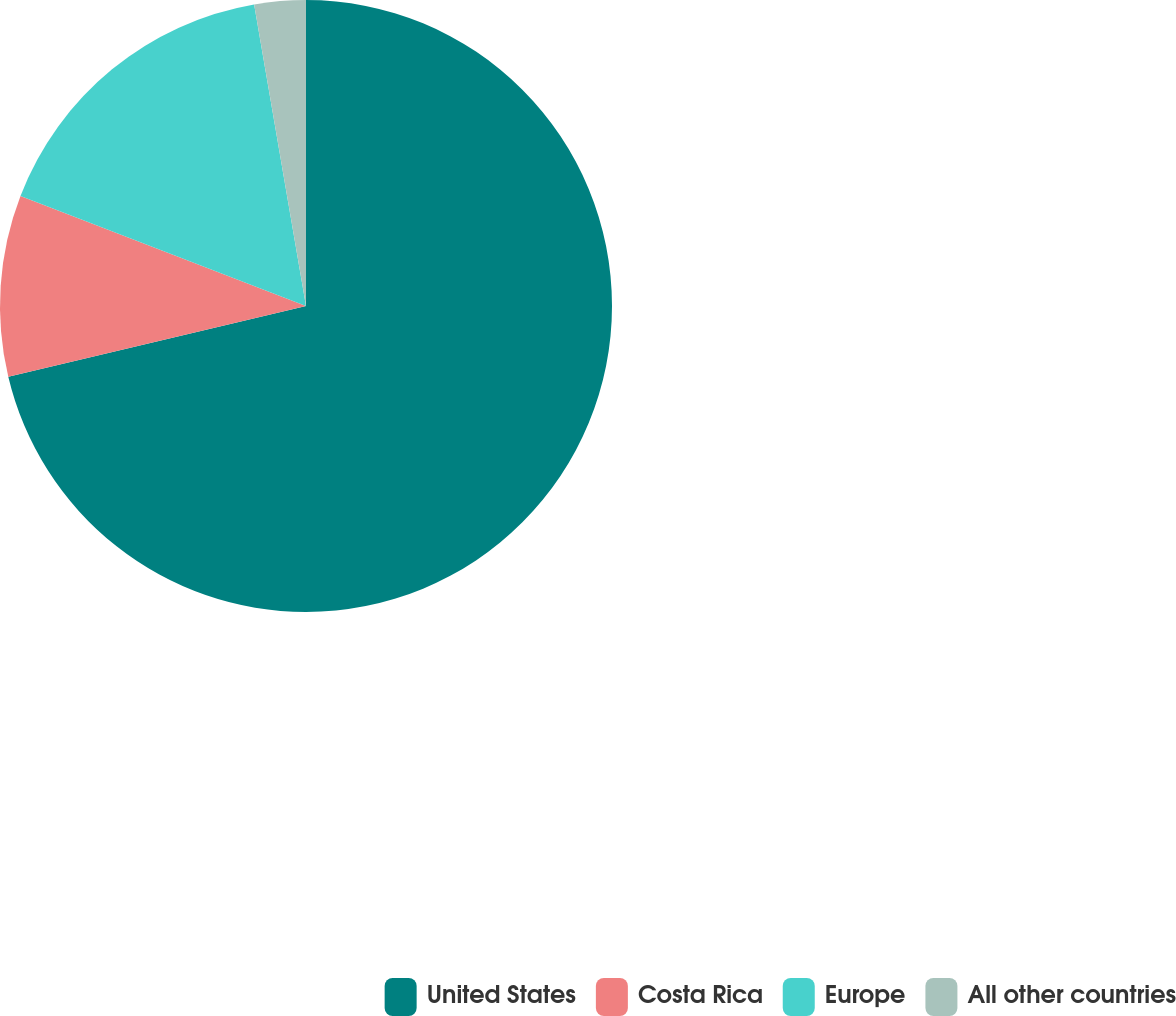Convert chart to OTSL. <chart><loc_0><loc_0><loc_500><loc_500><pie_chart><fcel>United States<fcel>Costa Rica<fcel>Europe<fcel>All other countries<nl><fcel>71.28%<fcel>9.57%<fcel>16.43%<fcel>2.71%<nl></chart> 